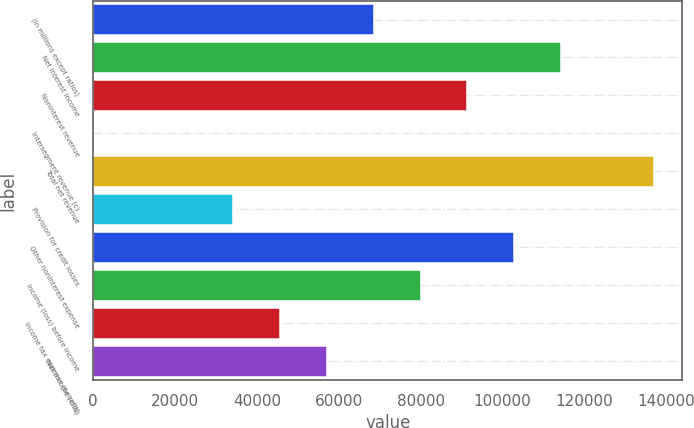<chart> <loc_0><loc_0><loc_500><loc_500><bar_chart><fcel>(in millions except ratios)<fcel>Net interest income<fcel>Noninterest revenue<fcel>Intersegment revenue (c)<fcel>Total net revenue<fcel>Provision for credit losses<fcel>Other noninterest expense<fcel>Income (loss) before income<fcel>Income tax expense (benefit)<fcel>Net income (loss)<nl><fcel>68555.2<fcel>114248<fcel>91401.6<fcel>16<fcel>137094<fcel>34285.6<fcel>102825<fcel>79978.4<fcel>45708.8<fcel>57132<nl></chart> 